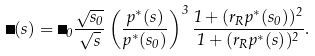<formula> <loc_0><loc_0><loc_500><loc_500>\Gamma ( s ) = \Gamma _ { 0 } \frac { \sqrt { s _ { 0 } } } { \sqrt { s } } \left ( \frac { p ^ { * } ( s ) } { p ^ { * } ( s _ { 0 } ) } \right ) ^ { 3 } \frac { 1 + ( r _ { R } p ^ { * } ( s _ { 0 } ) ) ^ { 2 } } { 1 + ( r _ { R } p ^ { * } ( s ) ) ^ { 2 } } .</formula> 